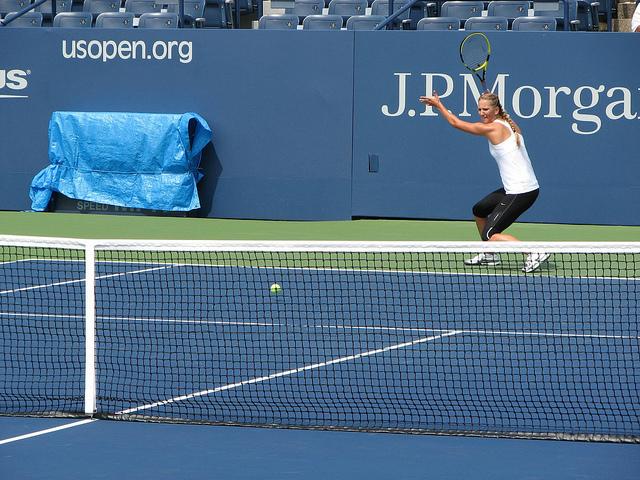Is this the US Open tournament?
Concise answer only. Yes. Can you see a tennis net?
Give a very brief answer. Yes. What is the official website of this event?
Give a very brief answer. Usopen.org. 